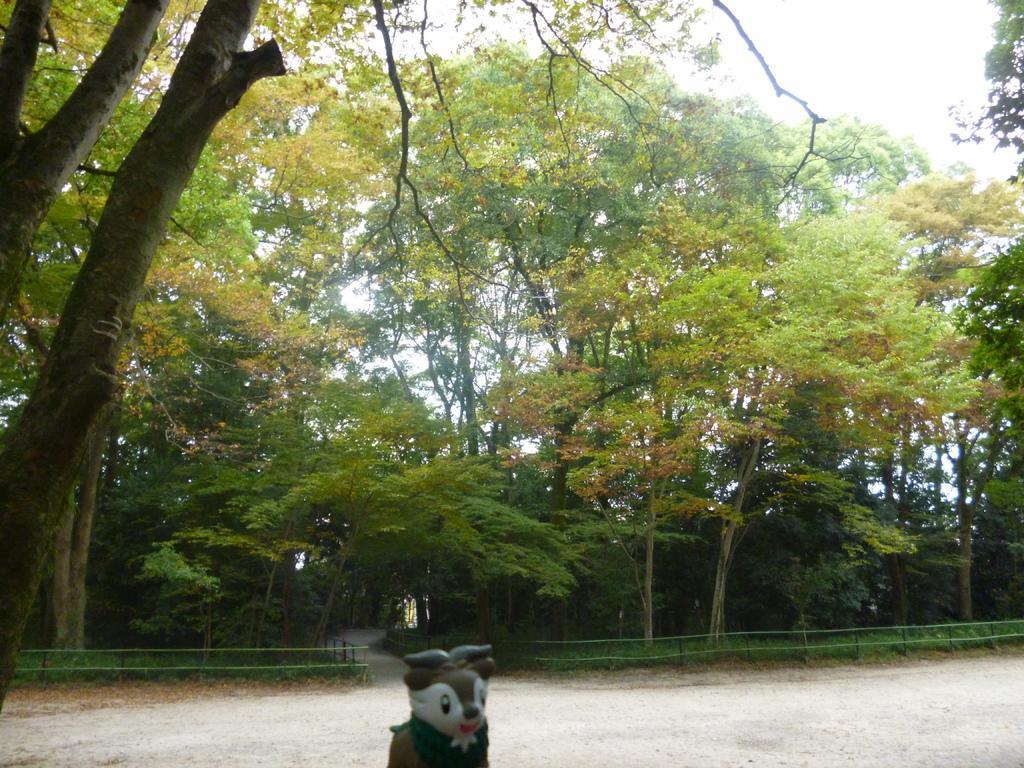Can you describe this image briefly? At the bottom of the image we can see a doll. In the center there are trees and we can see a fence. In the background there is sky. 